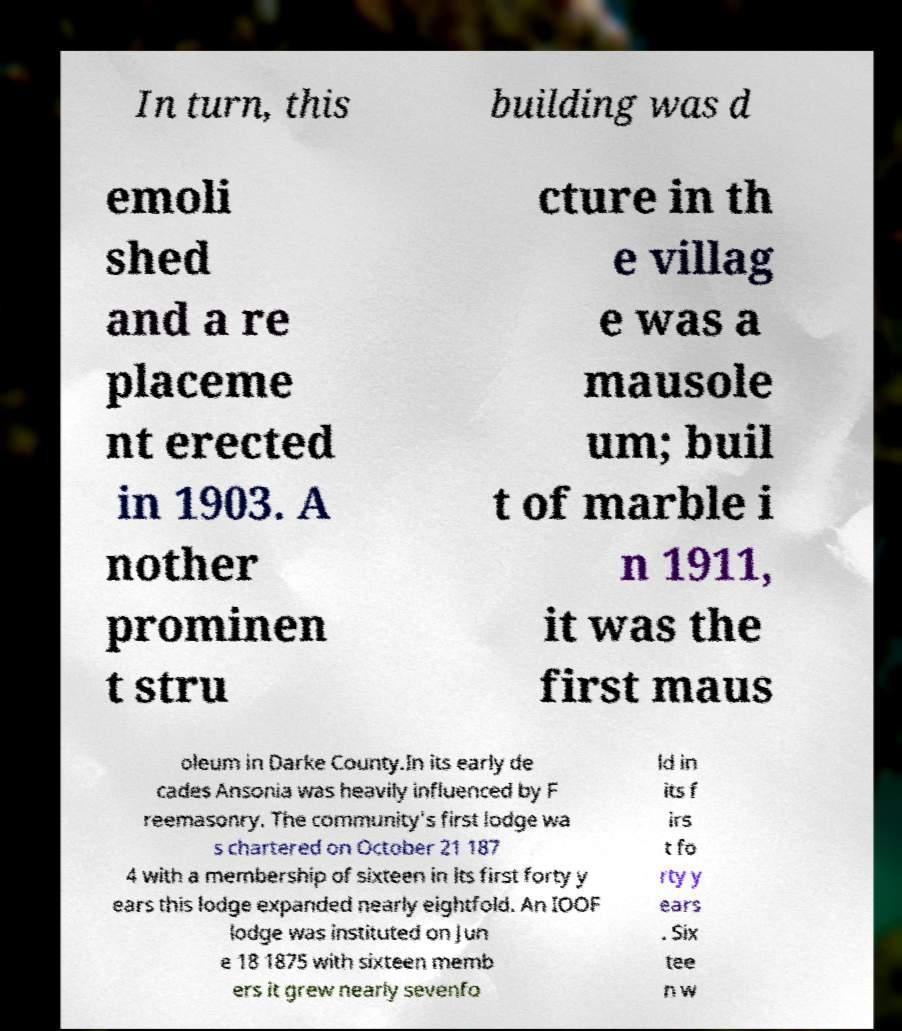What messages or text are displayed in this image? I need them in a readable, typed format. In turn, this building was d emoli shed and a re placeme nt erected in 1903. A nother prominen t stru cture in th e villag e was a mausole um; buil t of marble i n 1911, it was the first maus oleum in Darke County.In its early de cades Ansonia was heavily influenced by F reemasonry. The community's first lodge wa s chartered on October 21 187 4 with a membership of sixteen in its first forty y ears this lodge expanded nearly eightfold. An IOOF lodge was instituted on Jun e 18 1875 with sixteen memb ers it grew nearly sevenfo ld in its f irs t fo rty y ears . Six tee n w 